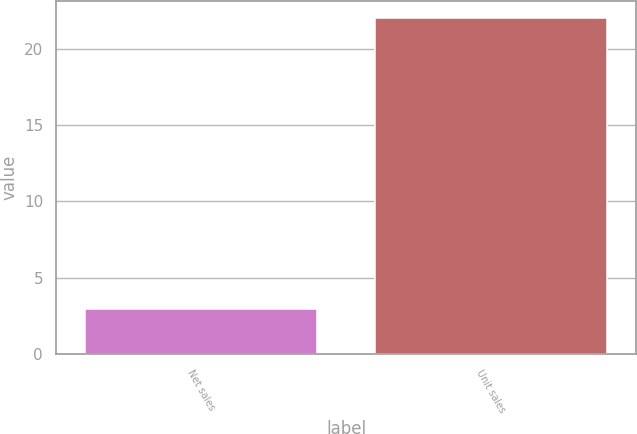Convert chart. <chart><loc_0><loc_0><loc_500><loc_500><bar_chart><fcel>Net sales<fcel>Unit sales<nl><fcel>3<fcel>22<nl></chart> 